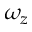<formula> <loc_0><loc_0><loc_500><loc_500>\omega _ { z }</formula> 